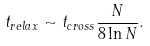<formula> <loc_0><loc_0><loc_500><loc_500>t _ { r e l a x } \sim t _ { c r o s s } \frac { N } { 8 \ln N } .</formula> 